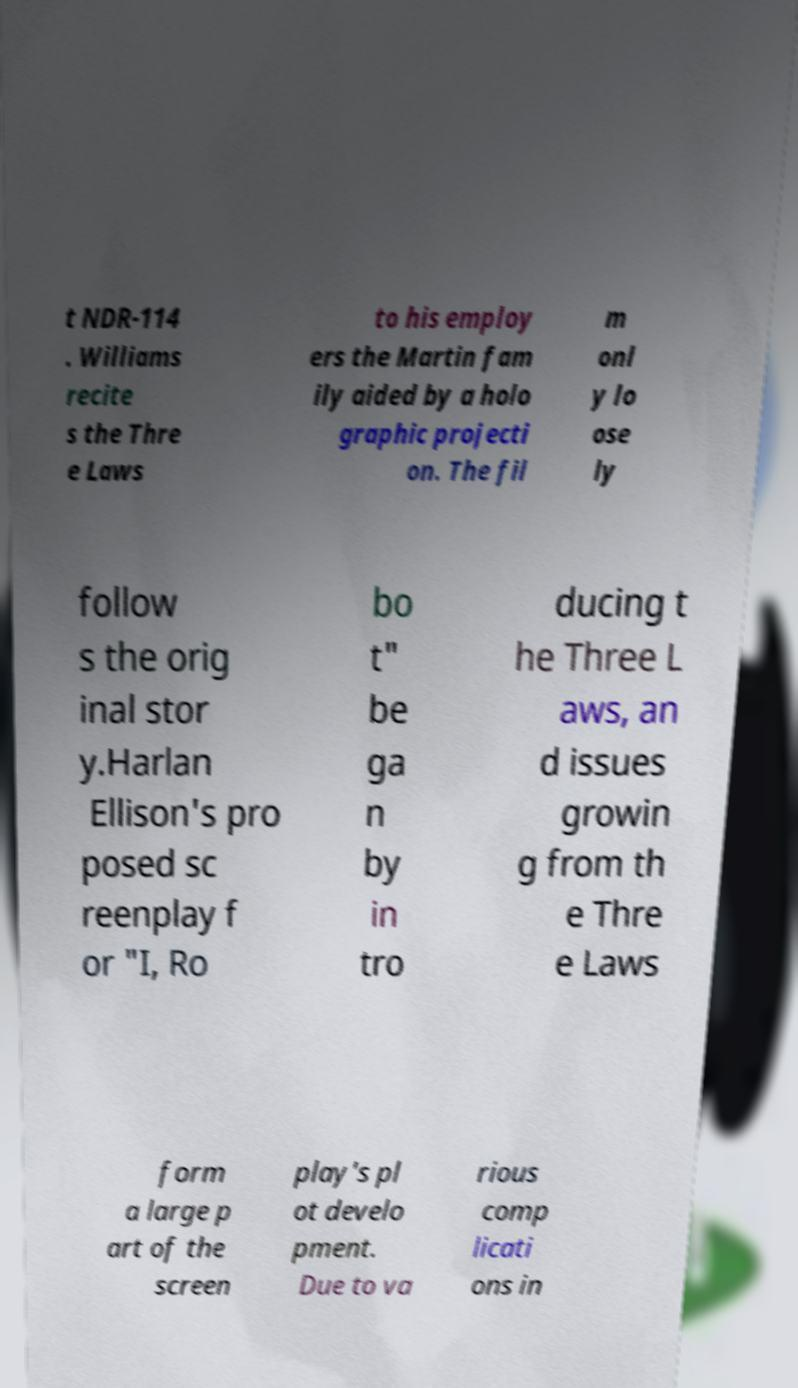Please identify and transcribe the text found in this image. t NDR-114 . Williams recite s the Thre e Laws to his employ ers the Martin fam ily aided by a holo graphic projecti on. The fil m onl y lo ose ly follow s the orig inal stor y.Harlan Ellison's pro posed sc reenplay f or "I, Ro bo t" be ga n by in tro ducing t he Three L aws, an d issues growin g from th e Thre e Laws form a large p art of the screen play's pl ot develo pment. Due to va rious comp licati ons in 